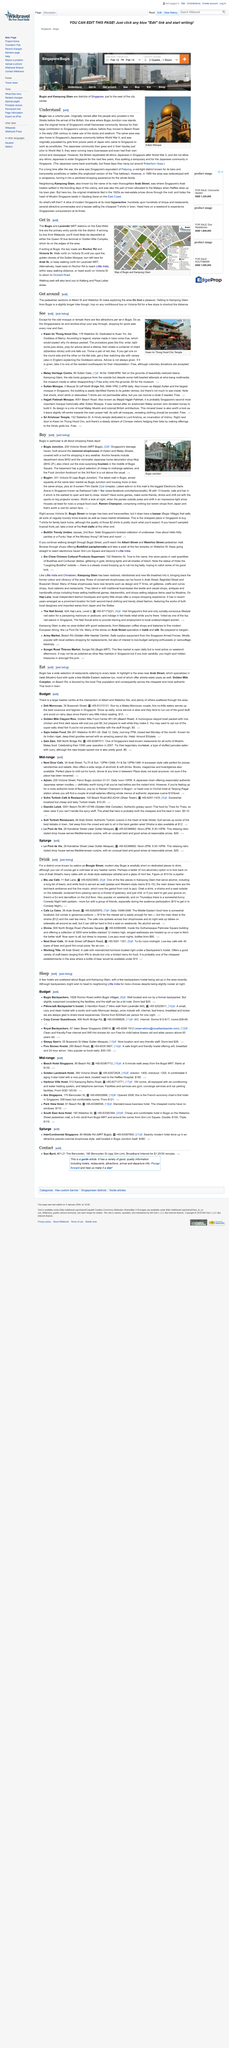Identify some key points in this picture. The temple dedicated to Kuan Yin and located in Bugis, Singapore, is called Kwan Im Thong Hood Cho Temple. The Sultan Mosque has golden domes that are a prominent feature of its architectural design. The image depicts a mosque, which is located in the building. The street address of the Kwan Im Thong Hood Cho temple is located at 178 Waterloo St. in Singapore. Yes, the Kwan Im Thong Hood Cho temple is free to visit. 